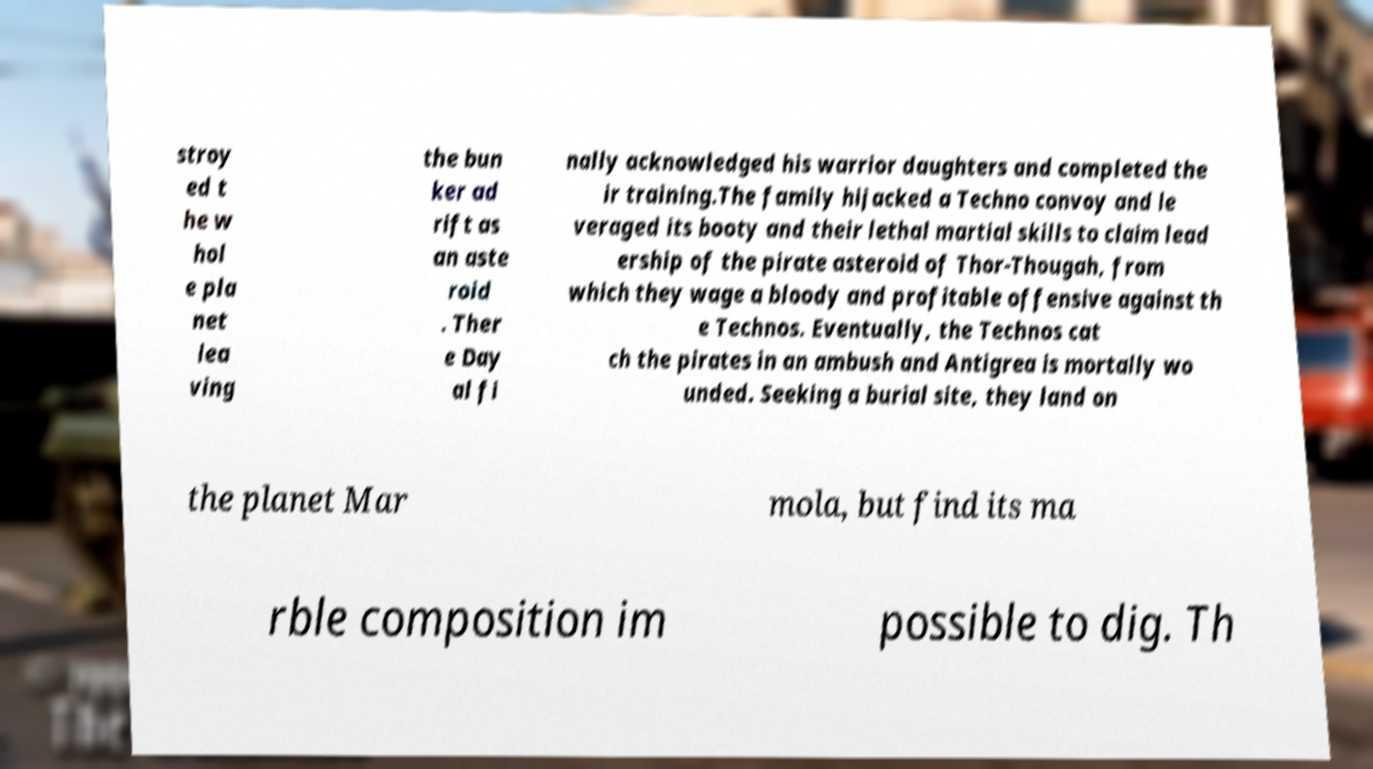Could you assist in decoding the text presented in this image and type it out clearly? stroy ed t he w hol e pla net lea ving the bun ker ad rift as an aste roid . Ther e Day al fi nally acknowledged his warrior daughters and completed the ir training.The family hijacked a Techno convoy and le veraged its booty and their lethal martial skills to claim lead ership of the pirate asteroid of Thor-Thougah, from which they wage a bloody and profitable offensive against th e Technos. Eventually, the Technos cat ch the pirates in an ambush and Antigrea is mortally wo unded. Seeking a burial site, they land on the planet Mar mola, but find its ma rble composition im possible to dig. Th 